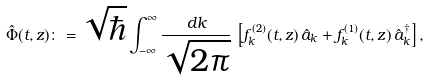Convert formula to latex. <formula><loc_0><loc_0><loc_500><loc_500>\hat { \Phi } ( t , z ) \colon = \sqrt { \hbar } \int _ { - \infty } ^ { \infty } \frac { d k } { \sqrt { 2 \pi } } \, \left [ f _ { k } ^ { ( 2 ) } ( t , z ) \, \hat { a } _ { k } + f _ { k } ^ { ( 1 ) } ( t , z ) \, \hat { a } _ { k } ^ { \dagger } \right ] ,</formula> 